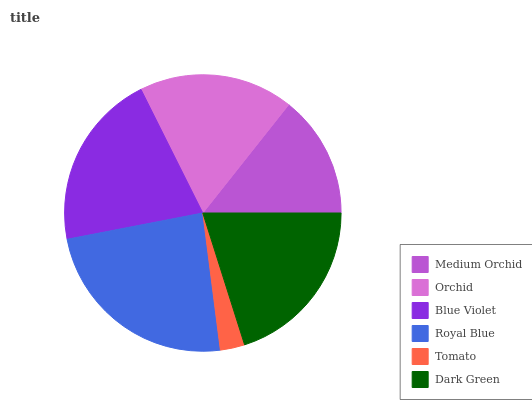Is Tomato the minimum?
Answer yes or no. Yes. Is Royal Blue the maximum?
Answer yes or no. Yes. Is Orchid the minimum?
Answer yes or no. No. Is Orchid the maximum?
Answer yes or no. No. Is Orchid greater than Medium Orchid?
Answer yes or no. Yes. Is Medium Orchid less than Orchid?
Answer yes or no. Yes. Is Medium Orchid greater than Orchid?
Answer yes or no. No. Is Orchid less than Medium Orchid?
Answer yes or no. No. Is Dark Green the high median?
Answer yes or no. Yes. Is Orchid the low median?
Answer yes or no. Yes. Is Medium Orchid the high median?
Answer yes or no. No. Is Blue Violet the low median?
Answer yes or no. No. 